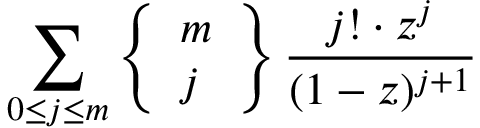<formula> <loc_0><loc_0><loc_500><loc_500>\sum _ { 0 \leq j \leq m } \left \{ { \begin{array} { l } { m } \\ { j } \end{array} } \right \} { \frac { j ! \cdot z ^ { j } } { ( 1 - z ) ^ { j + 1 } } }</formula> 